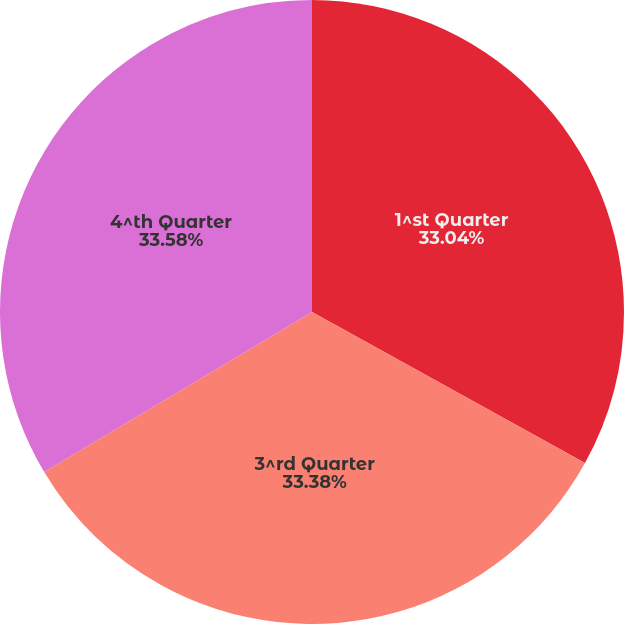Convert chart to OTSL. <chart><loc_0><loc_0><loc_500><loc_500><pie_chart><fcel>1^st Quarter<fcel>3^rd Quarter<fcel>4^th Quarter<nl><fcel>33.04%<fcel>33.38%<fcel>33.57%<nl></chart> 